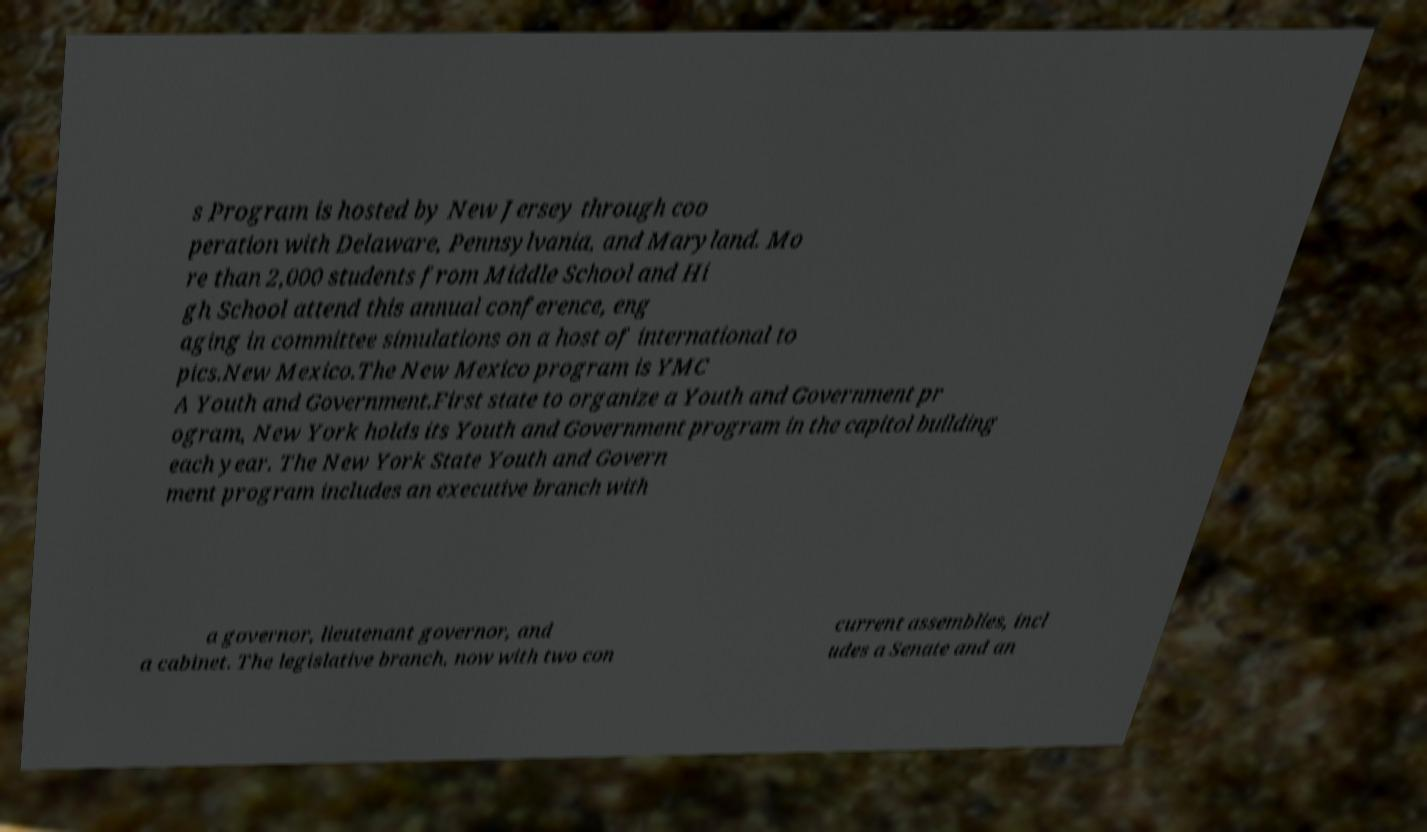Can you read and provide the text displayed in the image?This photo seems to have some interesting text. Can you extract and type it out for me? s Program is hosted by New Jersey through coo peration with Delaware, Pennsylvania, and Maryland. Mo re than 2,000 students from Middle School and Hi gh School attend this annual conference, eng aging in committee simulations on a host of international to pics.New Mexico.The New Mexico program is YMC A Youth and Government.First state to organize a Youth and Government pr ogram, New York holds its Youth and Government program in the capitol building each year. The New York State Youth and Govern ment program includes an executive branch with a governor, lieutenant governor, and a cabinet. The legislative branch, now with two con current assemblies, incl udes a Senate and an 